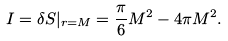Convert formula to latex. <formula><loc_0><loc_0><loc_500><loc_500>I = \delta S | _ { r = M } = \frac { \pi } { 6 } M ^ { 2 } - 4 \pi M ^ { 2 } .</formula> 